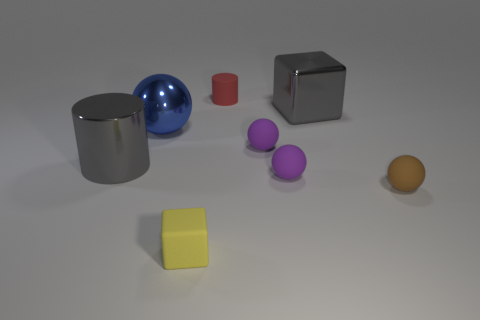Subtract all blue balls. How many balls are left? 3 Subtract all yellow spheres. Subtract all yellow cylinders. How many spheres are left? 4 Add 2 red matte cylinders. How many objects exist? 10 Subtract all blocks. How many objects are left? 6 Subtract 1 purple balls. How many objects are left? 7 Subtract all shiny objects. Subtract all tiny gray cubes. How many objects are left? 5 Add 7 matte cubes. How many matte cubes are left? 8 Add 6 small yellow cubes. How many small yellow cubes exist? 7 